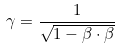Convert formula to latex. <formula><loc_0><loc_0><loc_500><loc_500>\gamma = \frac { 1 } { \sqrt { 1 - \beta \cdot \beta } }</formula> 